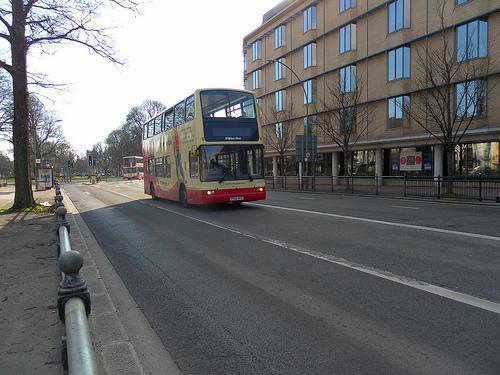How many buses are there?
Give a very brief answer. 2. 